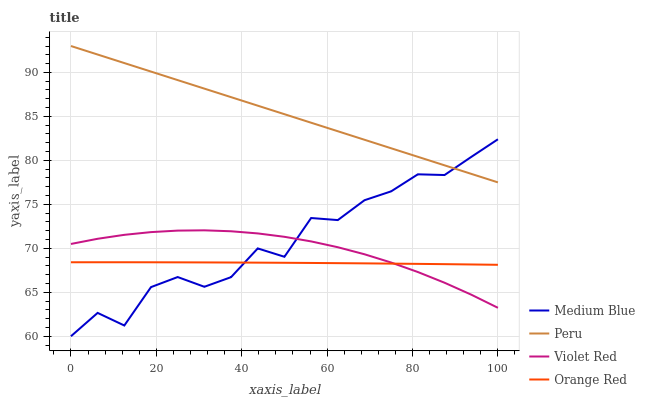Does Orange Red have the minimum area under the curve?
Answer yes or no. Yes. Does Peru have the maximum area under the curve?
Answer yes or no. Yes. Does Medium Blue have the minimum area under the curve?
Answer yes or no. No. Does Medium Blue have the maximum area under the curve?
Answer yes or no. No. Is Peru the smoothest?
Answer yes or no. Yes. Is Medium Blue the roughest?
Answer yes or no. Yes. Is Orange Red the smoothest?
Answer yes or no. No. Is Orange Red the roughest?
Answer yes or no. No. Does Orange Red have the lowest value?
Answer yes or no. No. Does Peru have the highest value?
Answer yes or no. Yes. Does Medium Blue have the highest value?
Answer yes or no. No. Is Orange Red less than Peru?
Answer yes or no. Yes. Is Peru greater than Violet Red?
Answer yes or no. Yes. Does Violet Red intersect Medium Blue?
Answer yes or no. Yes. Is Violet Red less than Medium Blue?
Answer yes or no. No. Is Violet Red greater than Medium Blue?
Answer yes or no. No. Does Orange Red intersect Peru?
Answer yes or no. No. 